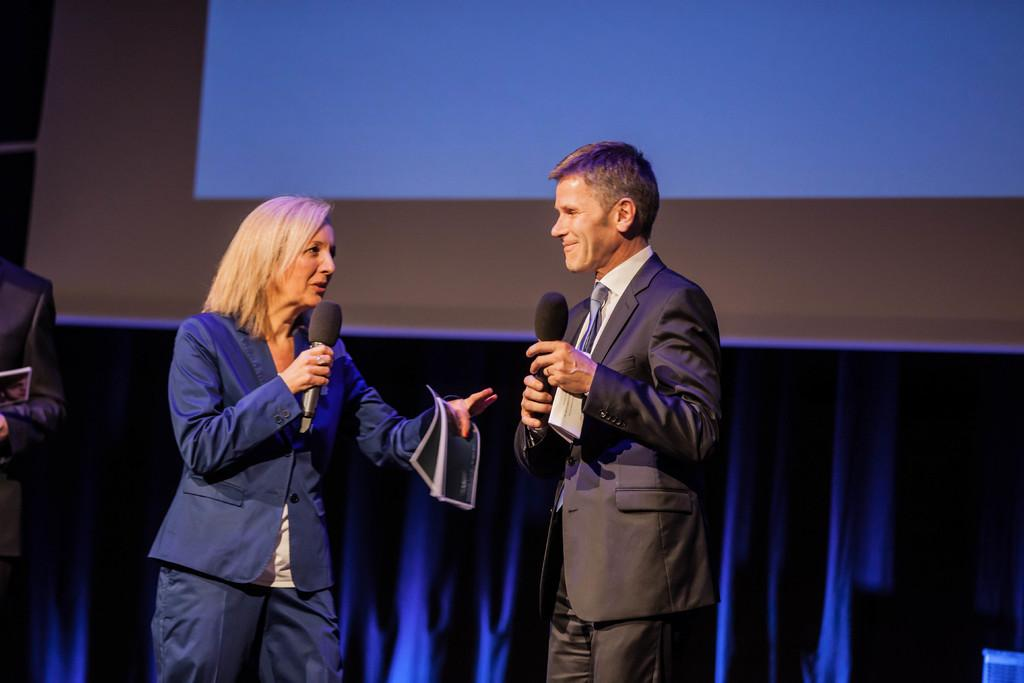Who is present in the image? There is a couple in the image. What are the couple wearing? Both individuals in the couple are wearing suits. What objects are the couple holding? The couple is holding microphones and papers. What invention can be seen in the hands of the couple in the image? There is no invention visible in the hands of the couple; they are holding microphones and papers. What type of rake is being used by the couple in the image? There is no rake present in the image; the couple is holding microphones and papers. 